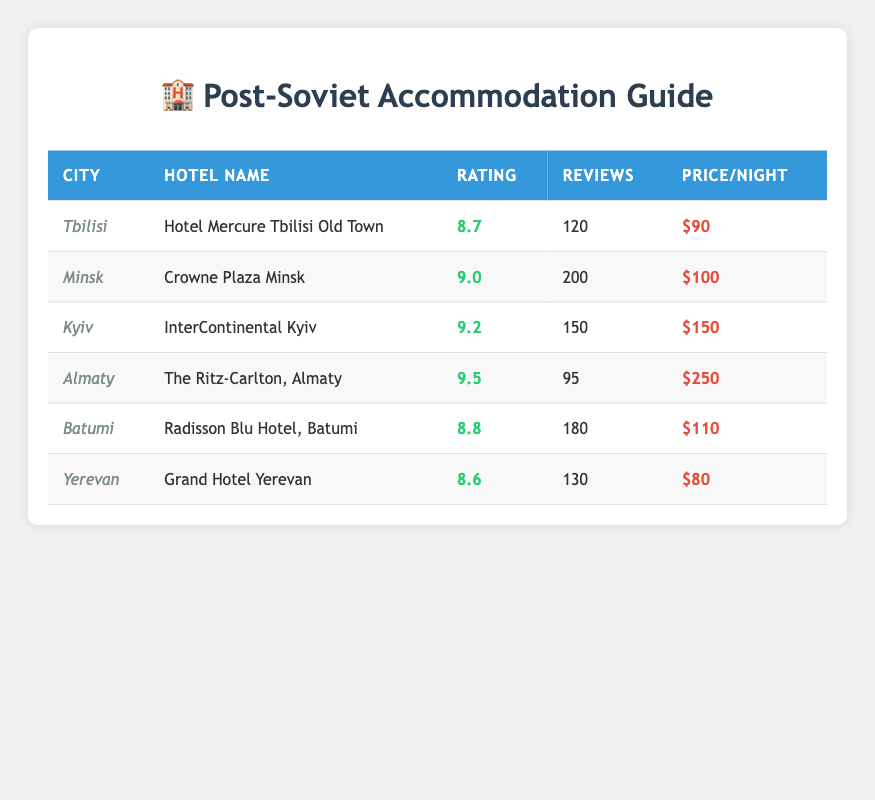What is the highest accommodation rating among the hotels listed? The table shows the ratings of each hotel. The highest rating is found in the row for "The Ritz-Carlton, Almaty" with a rating of 9.5.
Answer: 9.5 Which city has the cheapest hotel rate? To find the cheapest hotel, we compare the price per night for each hotel. "Grand Hotel Yerevan" has the price of $80, which is lower than all others in the table.
Answer: $80 How many reviews does the hotel with the highest rating have? The hotel with the highest rating is "The Ritz-Carlton, Almaty" with a rating of 9.5. Looking at the table, it has 95 reviews.
Answer: 95 Is there any hotel in Tbilisi that has a rating above 9? The table indicates that "Hotel Mercure Tbilisi Old Town" has a rating of 8.7 which is below 9. Therefore, there is no hotel in Tbilisi with a rating above 9.
Answer: No What is the average rating of all hotels listed? To calculate the average rating, we sum all the ratings (8.7 + 9.0 + 9.2 + 9.5 + 8.8 + 8.6 = 53.8) and then divide by the number of hotels (6). So, 53.8/6 = 8.9667.
Answer: 8.97 How much more expensive is the most expensive hotel compared to the cheapest one? The most expensive hotel is "The Ritz-Carlton, Almaty" at $250, and the cheapest is "Grand Hotel Yerevan" at $80. To find the difference, we subtract the lowest from the highest: 250 - 80 = 170.
Answer: $170 Which hotel has the highest number of reviews and what is that number? Looking at the review count, "Crowne Plaza Minsk" has 200 reviews, which is higher than any other hotel listed.
Answer: 200 Are there any hotels in the table that have a rating of 9.0 or above? Checking the ratings, "Crowne Plaza Minsk", "InterContinental Kyiv", and "The Ritz-Carlton, Almaty" all have ratings of 9.0 or higher.
Answer: Yes What is the total price of staying one night at all the hotels combined? By adding the price per night of all listed hotels (90 + 100 + 150 + 250 + 110 + 80), the total sum is 780.
Answer: $780 